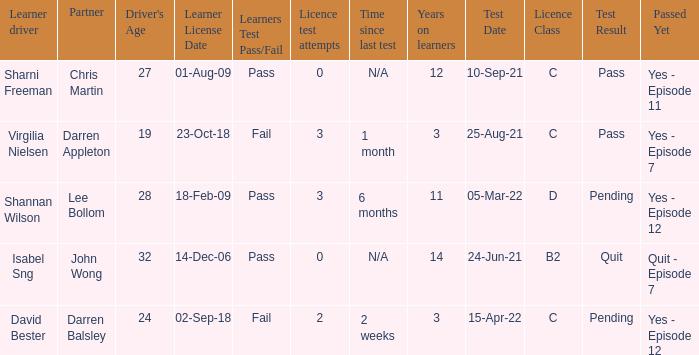What is the average number of years on learners of the drivers over the age of 24 with less than 0 attempts at the licence test? None. 